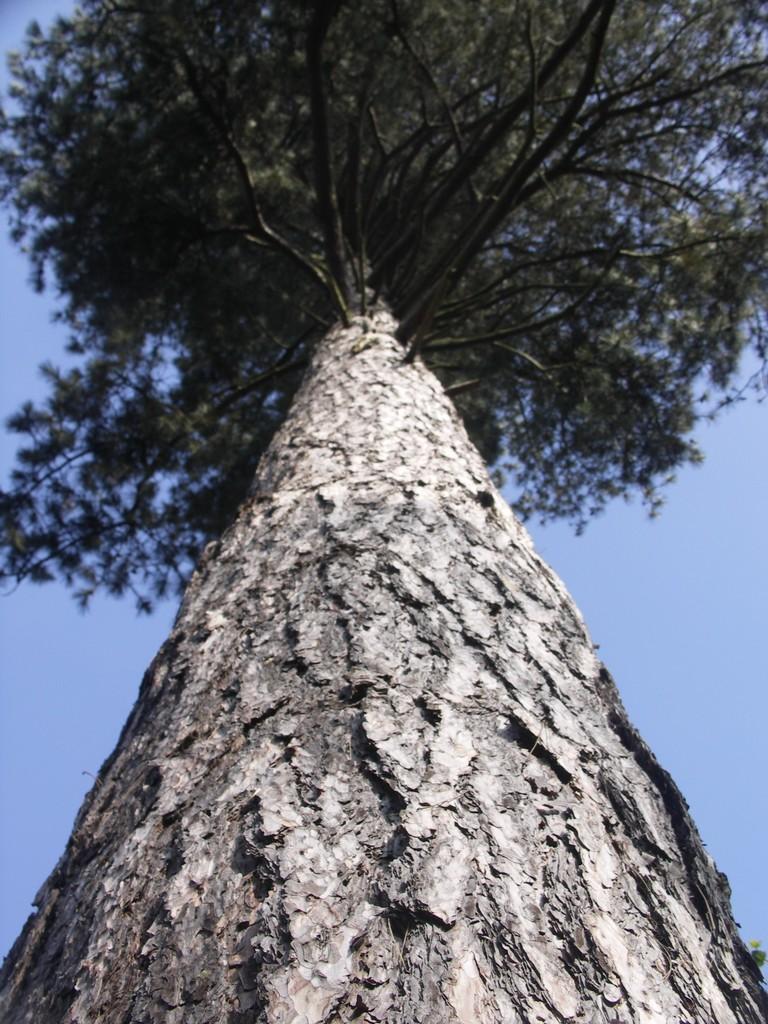Describe this image in one or two sentences. In this picture we can see a tree and in the background we can see the sky. 